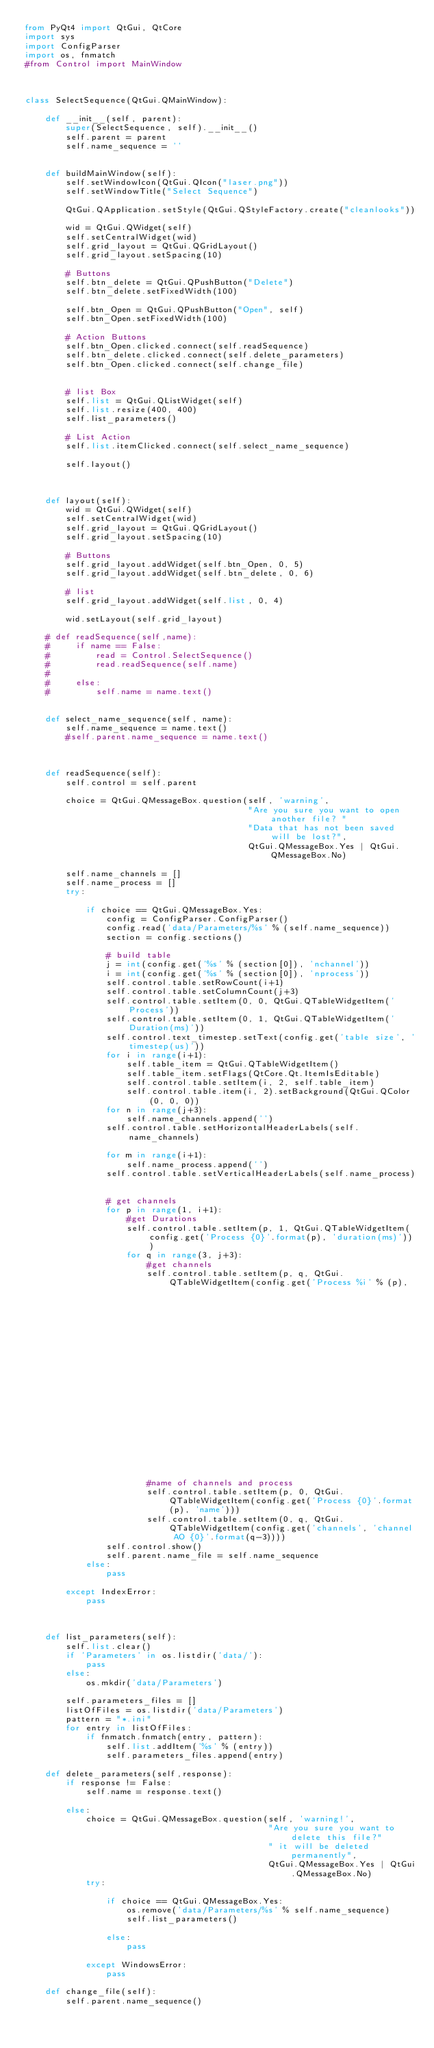Convert code to text. <code><loc_0><loc_0><loc_500><loc_500><_Python_>from PyQt4 import QtGui, QtCore
import sys
import ConfigParser
import os, fnmatch
#from Control import MainWindow



class SelectSequence(QtGui.QMainWindow):

    def __init__(self, parent):
        super(SelectSequence, self).__init__()
        self.parent = parent
        self.name_sequence = ''


    def buildMainWindow(self):
        self.setWindowIcon(QtGui.QIcon("laser.png"))
        self.setWindowTitle("Select Sequence")

        QtGui.QApplication.setStyle(QtGui.QStyleFactory.create("cleanlooks"))

        wid = QtGui.QWidget(self)
        self.setCentralWidget(wid)
        self.grid_layout = QtGui.QGridLayout()
        self.grid_layout.setSpacing(10)

        # Buttons
        self.btn_delete = QtGui.QPushButton("Delete")
        self.btn_delete.setFixedWidth(100)

        self.btn_Open = QtGui.QPushButton("Open", self)
        self.btn_Open.setFixedWidth(100)

        # Action Buttons
        self.btn_Open.clicked.connect(self.readSequence)
        self.btn_delete.clicked.connect(self.delete_parameters)
        self.btn_Open.clicked.connect(self.change_file)


        # list Box
        self.list = QtGui.QListWidget(self)
        self.list.resize(400, 400)
        self.list_parameters()

        # List Action
        self.list.itemClicked.connect(self.select_name_sequence)

        self.layout()



    def layout(self):
        wid = QtGui.QWidget(self)
        self.setCentralWidget(wid)
        self.grid_layout = QtGui.QGridLayout()
        self.grid_layout.setSpacing(10)

        # Buttons
        self.grid_layout.addWidget(self.btn_Open, 0, 5)
        self.grid_layout.addWidget(self.btn_delete, 0, 6)

        # list
        self.grid_layout.addWidget(self.list, 0, 4)

        wid.setLayout(self.grid_layout)

    # def readSequence(self,name):
    #     if name == False:
    #         read = Control.SelectSequence()
    #         read.readSequence(self.name)
    #
    #     else:
    #         self.name = name.text()


    def select_name_sequence(self, name):
        self.name_sequence = name.text()
        #self.parent.name_sequence = name.text()



    def readSequence(self):
        self.control = self.parent

        choice = QtGui.QMessageBox.question(self, 'warning',
                                            "Are you sure you want to open another file? "
                                            "Data that has not been saved will be lost?",
                                            QtGui.QMessageBox.Yes | QtGui.QMessageBox.No)

        self.name_channels = []
        self.name_process = []
        try:

            if choice == QtGui.QMessageBox.Yes:
                config = ConfigParser.ConfigParser()
                config.read('data/Parameters/%s' % (self.name_sequence))
                section = config.sections()

                # build table
                j = int(config.get('%s' % (section[0]), 'nchannel'))
                i = int(config.get('%s' % (section[0]), 'nprocess'))
                self.control.table.setRowCount(i+1)
                self.control.table.setColumnCount(j+3)
                self.control.table.setItem(0, 0, QtGui.QTableWidgetItem('Process'))
                self.control.table.setItem(0, 1, QtGui.QTableWidgetItem('Duration(ms)'))
                self.control.text_timestep.setText(config.get('table size', 'timestep(us)'))
                for i in range(i+1):
                    self.table_item = QtGui.QTableWidgetItem()
                    self.table_item.setFlags(QtCore.Qt.ItemIsEditable)
                    self.control.table.setItem(i, 2, self.table_item)
                    self.control.table.item(i, 2).setBackground(QtGui.QColor(0, 0, 0))
                for n in range(j+3):
                    self.name_channels.append('')
                self.control.table.setHorizontalHeaderLabels(self.name_channels)

                for m in range(i+1):
                    self.name_process.append('')
                self.control.table.setVerticalHeaderLabels(self.name_process)


                # get channels
                for p in range(1, i+1):
                    #get Durations
                    self.control.table.setItem(p, 1, QtGui.QTableWidgetItem(config.get('Process {0}'.format(p), 'duration(ms)')))
                    for q in range(3, j+3):
                        #get channels
                        self.control.table.setItem(p, q, QtGui.QTableWidgetItem(config.get('Process %i' % (p),
                                                                                   'channel AO %i value' % (q-3))))

                        #name of channels and process
                        self.control.table.setItem(p, 0, QtGui.QTableWidgetItem(config.get('Process {0}'.format(p), 'name')))
                        self.control.table.setItem(0, q, QtGui.QTableWidgetItem(config.get('channels', 'channel AO {0}'.format(q-3))))
                self.control.show()
                self.parent.name_file = self.name_sequence
            else:
                pass

        except IndexError:
            pass



    def list_parameters(self):
        self.list.clear()
        if 'Parameters' in os.listdir('data/'):
            pass
        else:
            os.mkdir('data/Parameters')

        self.parameters_files = []
        listOfFiles = os.listdir('data/Parameters')
        pattern = "*.ini"
        for entry in listOfFiles:
            if fnmatch.fnmatch(entry, pattern):
                self.list.addItem('%s' % (entry))
                self.parameters_files.append(entry)

    def delete_parameters(self,response):
        if response != False:
            self.name = response.text()

        else:
            choice = QtGui.QMessageBox.question(self, 'warning!',
                                                "Are you sure you want to delete this file?"
                                                " it will be deleted permanently",
                                                QtGui.QMessageBox.Yes | QtGui.QMessageBox.No)
            try:

                if choice == QtGui.QMessageBox.Yes:
                    os.remove('data/Parameters/%s' % self.name_sequence)
                    self.list_parameters()

                else:
                    pass

            except WindowsError:
                pass

    def change_file(self):
        self.parent.name_sequence()

</code> 